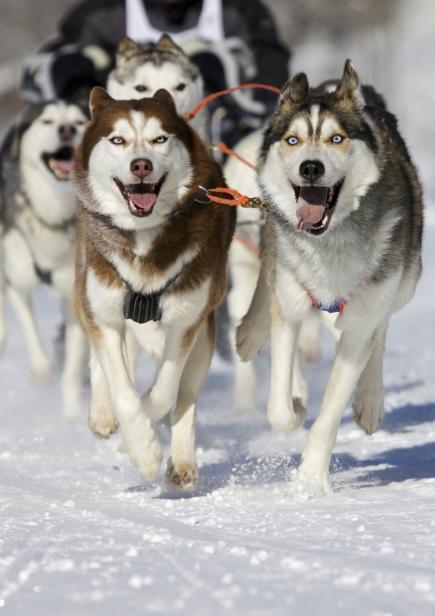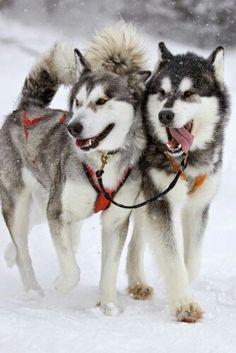The first image is the image on the left, the second image is the image on the right. Considering the images on both sides, is "One image shows a sled dog team headed forward, and the other image shows two side-by-side dogs, the one on the right with its tongue hanging out." valid? Answer yes or no. Yes. The first image is the image on the left, the second image is the image on the right. For the images shown, is this caption "There are two walking husky harness together with the one on the right sticking out their tongue." true? Answer yes or no. Yes. 